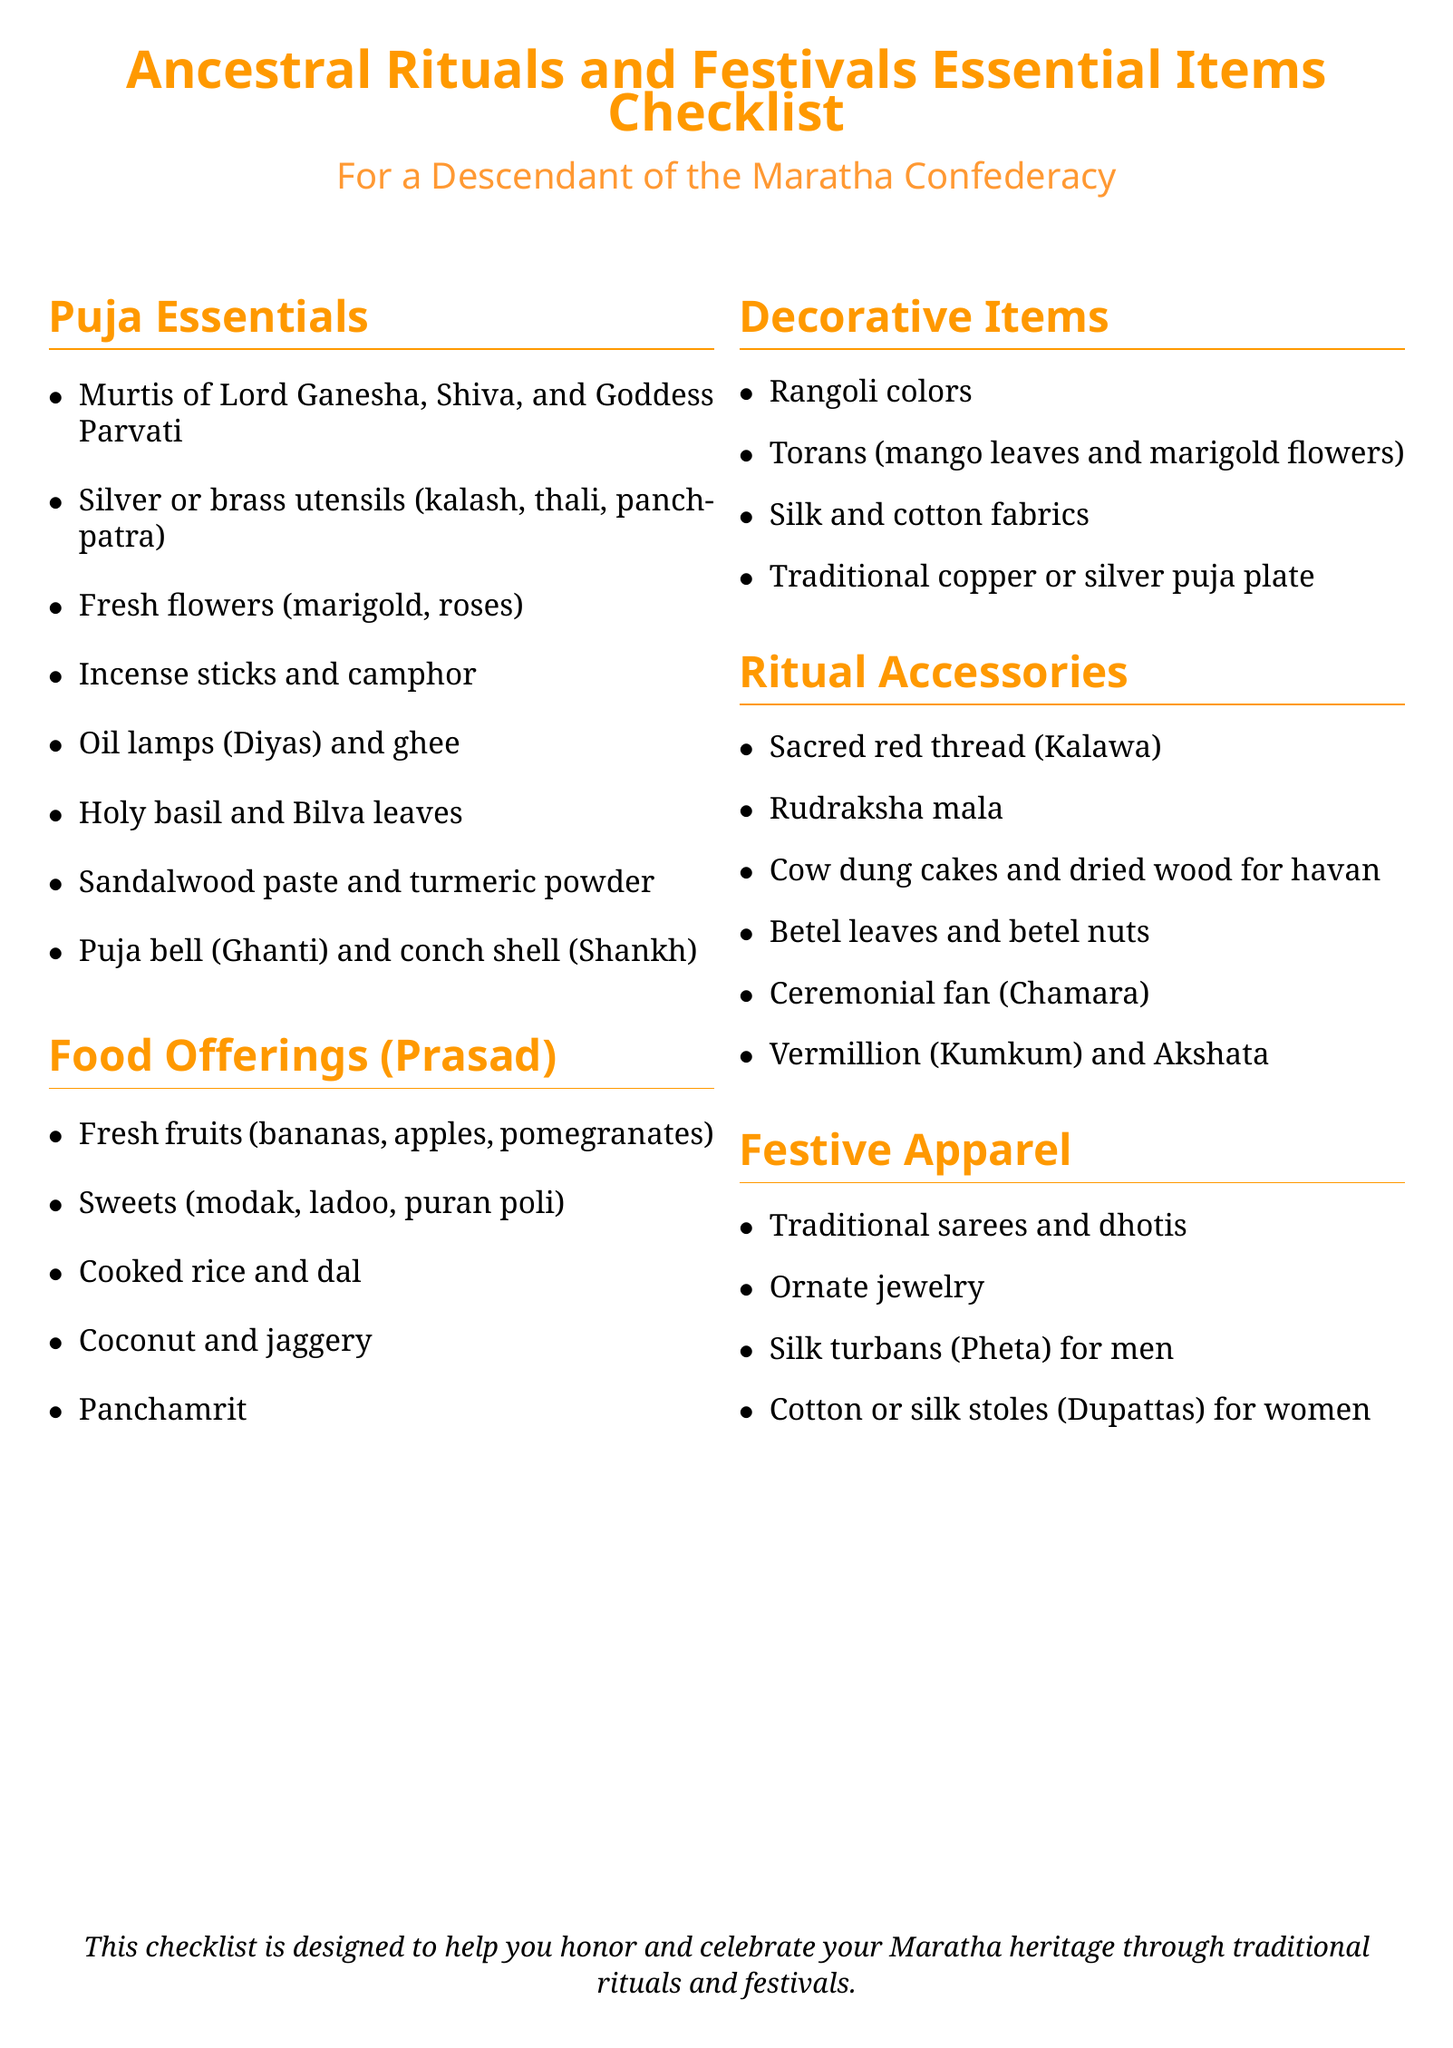What are the murtis included in the puja essentials? The puja essentials section lists the murtis that are required for the rituals, specifically Lord Ganesha, Shiva, and Goddess Parvati.
Answer: Lord Ganesha, Shiva, and Goddess Parvati What food offerings are mentioned in the checklist? The food offerings section specifies various items that can be offered, including fresh fruits, sweets, cooked rice, and more.
Answer: Fresh fruits, sweets, cooked rice, dal, coconut, jaggery, Panchamrit How many sections are there in this checklist? The document consists of multiple sections categorizing items, and these can be counted for the total sections present.
Answer: Five What is used for decoration according to the checklist? The decorative items section lists specific items that can be utilized for enhancing the aesthetic appeal during rituals and festivals.
Answer: Rangoli colors, torans, fabrics, puja plate Which item is mentioned as a ritual accessory that is also a sacred thread? The checklist includes various ritual accessories, with one specific item highlighted as a sacred thread which is commonly used during ancestral rituals.
Answer: Sacred red thread (Kalawa) What kind of apparel is suggested for festive occasions? The festive apparel section provides guidance on traditional clothing suitable for ceremonies and festivities, hinting at cultural attire.
Answer: Traditional sarees and dhotis What is the significance of the checklist? The checklist serves a purpose, specifically aimed at helping individuals honor and celebrate their heritage during rituals and festivals, which directly reflects its intention.
Answer: Honoring and celebrating Maratha heritage through traditional rituals and festivals 